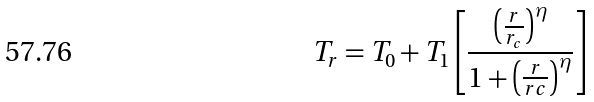<formula> <loc_0><loc_0><loc_500><loc_500>T _ { r } = T _ { 0 } + T _ { 1 } \left [ \frac { \left ( \frac { r } { r _ { c } } \right ) ^ { \eta } } { 1 + \left ( \frac { r } { r c } \right ) ^ { \eta } } \right ]</formula> 